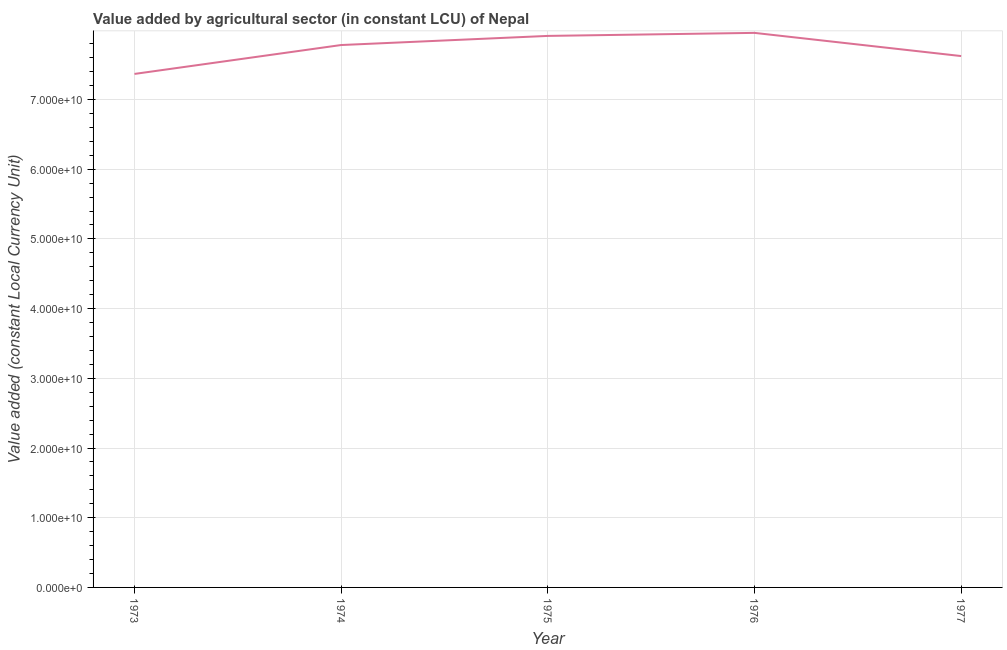What is the value added by agriculture sector in 1976?
Offer a terse response. 7.96e+1. Across all years, what is the maximum value added by agriculture sector?
Make the answer very short. 7.96e+1. Across all years, what is the minimum value added by agriculture sector?
Your answer should be compact. 7.37e+1. In which year was the value added by agriculture sector maximum?
Provide a short and direct response. 1976. What is the sum of the value added by agriculture sector?
Make the answer very short. 3.86e+11. What is the difference between the value added by agriculture sector in 1975 and 1977?
Ensure brevity in your answer.  2.89e+09. What is the average value added by agriculture sector per year?
Your response must be concise. 7.73e+1. What is the median value added by agriculture sector?
Give a very brief answer. 7.78e+1. In how many years, is the value added by agriculture sector greater than 38000000000 LCU?
Give a very brief answer. 5. What is the ratio of the value added by agriculture sector in 1974 to that in 1977?
Your response must be concise. 1.02. Is the value added by agriculture sector in 1974 less than that in 1975?
Your answer should be very brief. Yes. Is the difference between the value added by agriculture sector in 1973 and 1975 greater than the difference between any two years?
Your answer should be very brief. No. What is the difference between the highest and the second highest value added by agriculture sector?
Offer a very short reply. 4.34e+08. Is the sum of the value added by agriculture sector in 1975 and 1976 greater than the maximum value added by agriculture sector across all years?
Ensure brevity in your answer.  Yes. What is the difference between the highest and the lowest value added by agriculture sector?
Offer a very short reply. 5.89e+09. In how many years, is the value added by agriculture sector greater than the average value added by agriculture sector taken over all years?
Your answer should be compact. 3. Does the graph contain any zero values?
Your answer should be very brief. No. Does the graph contain grids?
Your answer should be very brief. Yes. What is the title of the graph?
Offer a terse response. Value added by agricultural sector (in constant LCU) of Nepal. What is the label or title of the Y-axis?
Provide a succinct answer. Value added (constant Local Currency Unit). What is the Value added (constant Local Currency Unit) in 1973?
Your response must be concise. 7.37e+1. What is the Value added (constant Local Currency Unit) of 1974?
Offer a terse response. 7.78e+1. What is the Value added (constant Local Currency Unit) of 1975?
Offer a very short reply. 7.91e+1. What is the Value added (constant Local Currency Unit) of 1976?
Ensure brevity in your answer.  7.96e+1. What is the Value added (constant Local Currency Unit) in 1977?
Provide a succinct answer. 7.62e+1. What is the difference between the Value added (constant Local Currency Unit) in 1973 and 1974?
Ensure brevity in your answer.  -4.15e+09. What is the difference between the Value added (constant Local Currency Unit) in 1973 and 1975?
Your response must be concise. -5.46e+09. What is the difference between the Value added (constant Local Currency Unit) in 1973 and 1976?
Provide a short and direct response. -5.89e+09. What is the difference between the Value added (constant Local Currency Unit) in 1973 and 1977?
Keep it short and to the point. -2.56e+09. What is the difference between the Value added (constant Local Currency Unit) in 1974 and 1975?
Give a very brief answer. -1.31e+09. What is the difference between the Value added (constant Local Currency Unit) in 1974 and 1976?
Ensure brevity in your answer.  -1.74e+09. What is the difference between the Value added (constant Local Currency Unit) in 1974 and 1977?
Offer a terse response. 1.58e+09. What is the difference between the Value added (constant Local Currency Unit) in 1975 and 1976?
Your answer should be very brief. -4.34e+08. What is the difference between the Value added (constant Local Currency Unit) in 1975 and 1977?
Offer a very short reply. 2.89e+09. What is the difference between the Value added (constant Local Currency Unit) in 1976 and 1977?
Give a very brief answer. 3.33e+09. What is the ratio of the Value added (constant Local Currency Unit) in 1973 to that in 1974?
Ensure brevity in your answer.  0.95. What is the ratio of the Value added (constant Local Currency Unit) in 1973 to that in 1975?
Give a very brief answer. 0.93. What is the ratio of the Value added (constant Local Currency Unit) in 1973 to that in 1976?
Give a very brief answer. 0.93. What is the ratio of the Value added (constant Local Currency Unit) in 1973 to that in 1977?
Keep it short and to the point. 0.97. What is the ratio of the Value added (constant Local Currency Unit) in 1974 to that in 1976?
Offer a terse response. 0.98. What is the ratio of the Value added (constant Local Currency Unit) in 1974 to that in 1977?
Ensure brevity in your answer.  1.02. What is the ratio of the Value added (constant Local Currency Unit) in 1975 to that in 1976?
Keep it short and to the point. 0.99. What is the ratio of the Value added (constant Local Currency Unit) in 1975 to that in 1977?
Your answer should be very brief. 1.04. What is the ratio of the Value added (constant Local Currency Unit) in 1976 to that in 1977?
Offer a terse response. 1.04. 